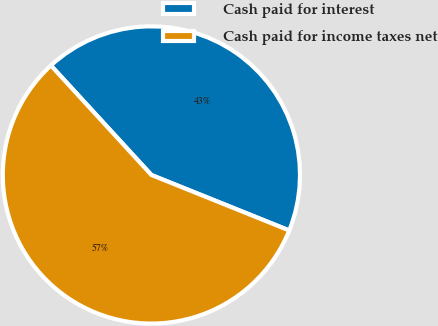Convert chart to OTSL. <chart><loc_0><loc_0><loc_500><loc_500><pie_chart><fcel>Cash paid for interest<fcel>Cash paid for income taxes net<nl><fcel>42.91%<fcel>57.09%<nl></chart> 